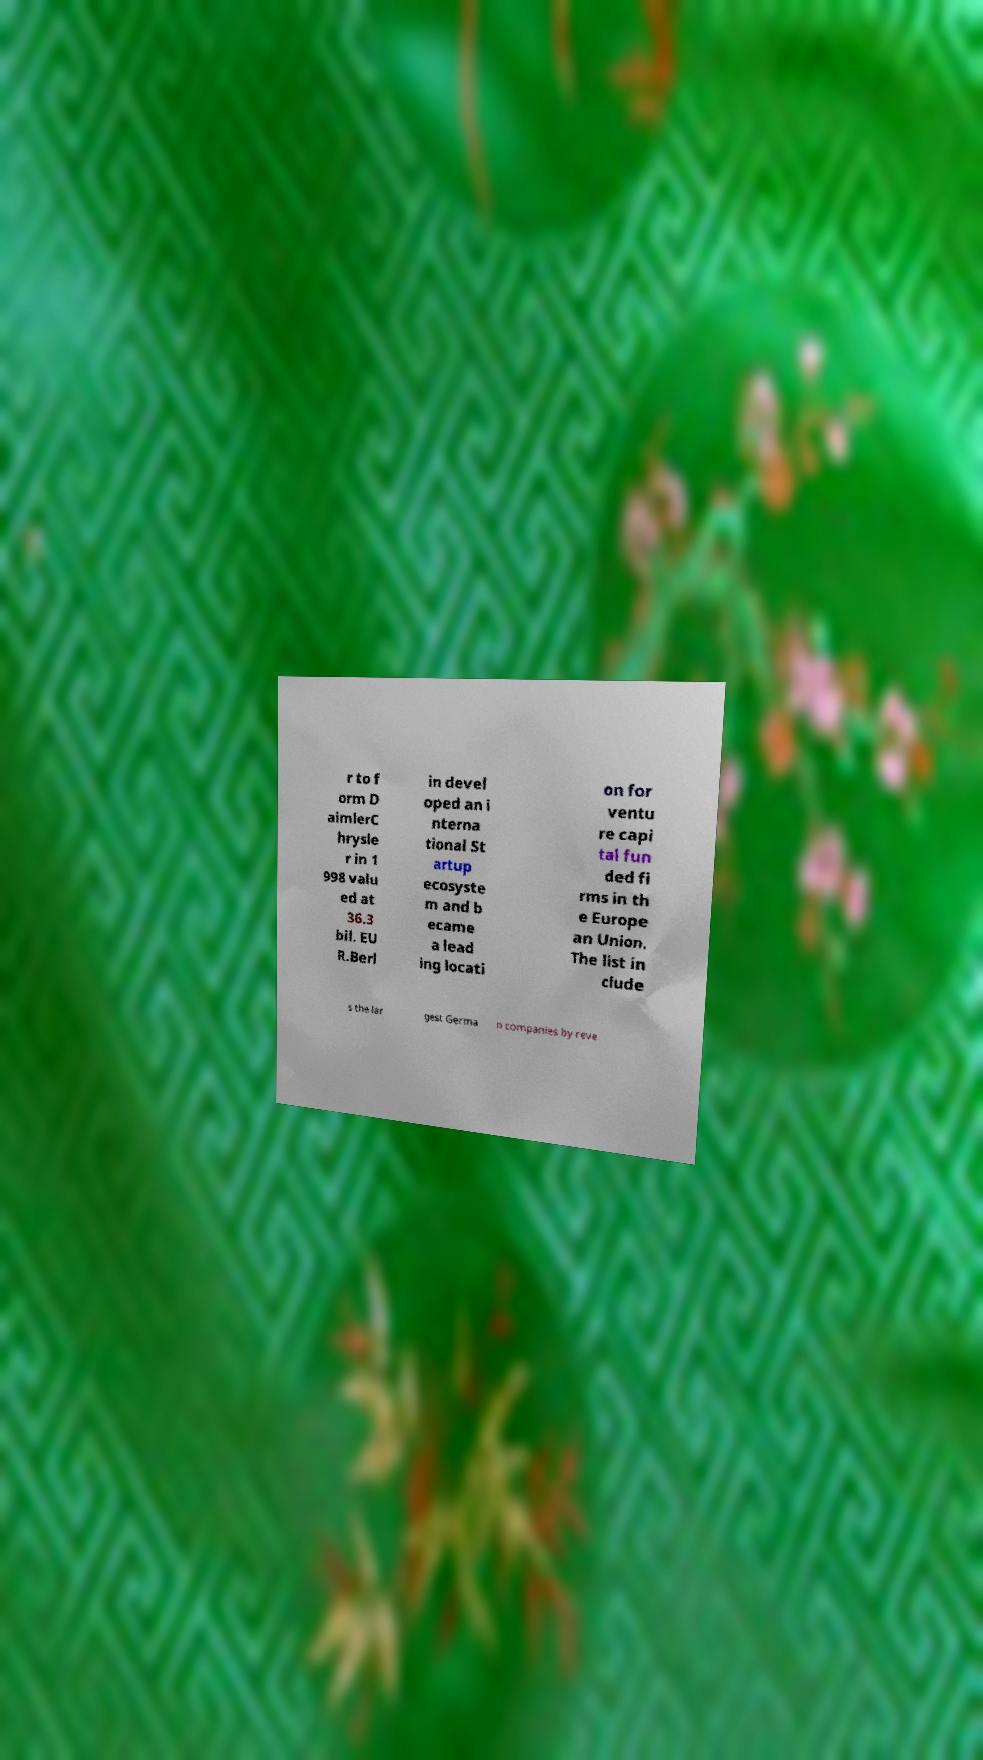Please read and relay the text visible in this image. What does it say? r to f orm D aimlerC hrysle r in 1 998 valu ed at 36.3 bil. EU R.Berl in devel oped an i nterna tional St artup ecosyste m and b ecame a lead ing locati on for ventu re capi tal fun ded fi rms in th e Europe an Union. The list in clude s the lar gest Germa n companies by reve 